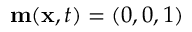Convert formula to latex. <formula><loc_0><loc_0><loc_500><loc_500>m ( x , t ) = ( 0 , 0 , 1 )</formula> 